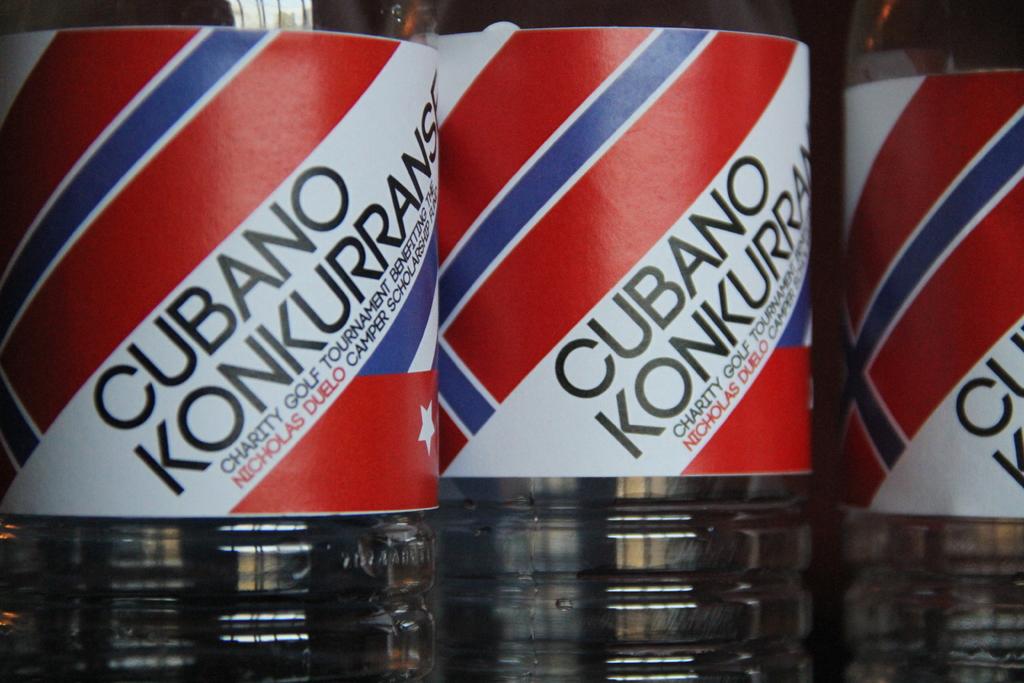What type of tournament is being advertised?
Your answer should be very brief. Golf. What is the name of the tournament?
Offer a terse response. Cubano konkurranse. 